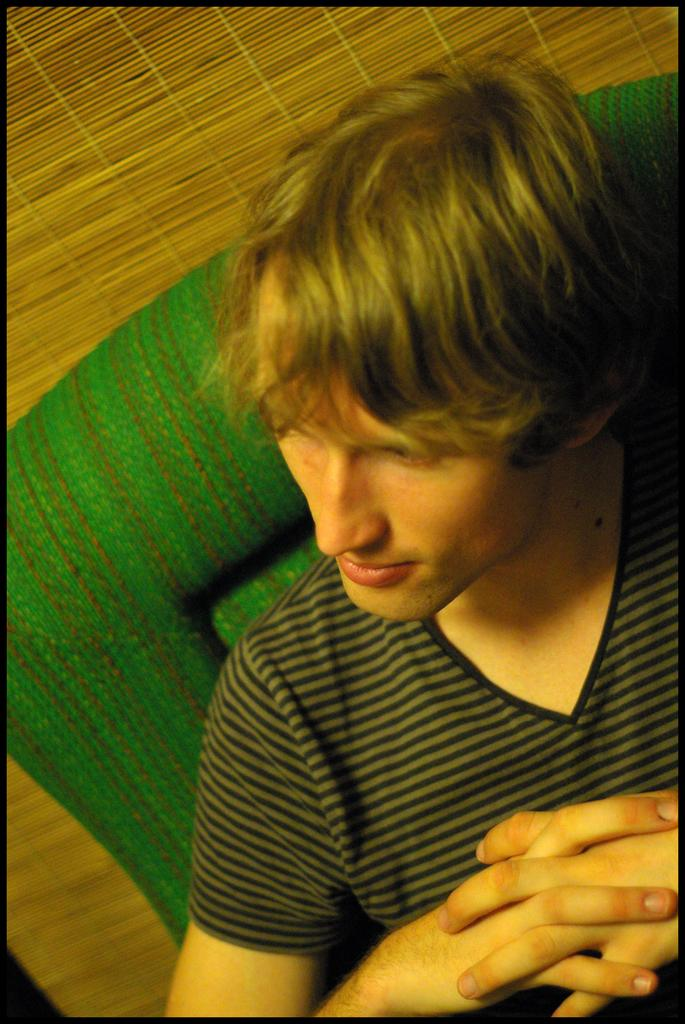Who is present in the image? There is a man in the image. What is the man sitting on? The man is sitting on a green chair. What is the man wearing? The man is wearing a t-shirt. What can be seen in the background of the image? There is a window in the background of the image. How many women are present in the image? There are no women present in the image; it features a man sitting on a green chair. What type of order is the man processing in the image? There is no indication of the man processing any order in the image. 